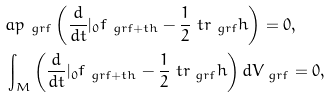Convert formula to latex. <formula><loc_0><loc_0><loc_500><loc_500>& \L a p _ { \ g r f } \left ( \frac { d } { d t } | _ { 0 } f _ { \ g r f + t h } - \frac { 1 } { 2 } \ t r _ { \ g r f } h \right ) = 0 , \\ & \int _ { M } \left ( \frac { d } { d t } | _ { 0 } f _ { \ g r f + t h } - \frac { 1 } { 2 } \ t r _ { \ g r f } h \right ) d V _ { \ g r f } = 0 ,</formula> 